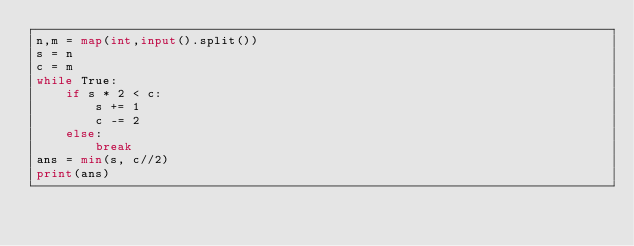<code> <loc_0><loc_0><loc_500><loc_500><_Python_>n,m = map(int,input().split())
s = n
c = m
while True:
    if s * 2 < c:
        s += 1
        c -= 2
    else:
        break
ans = min(s, c//2)
print(ans)</code> 